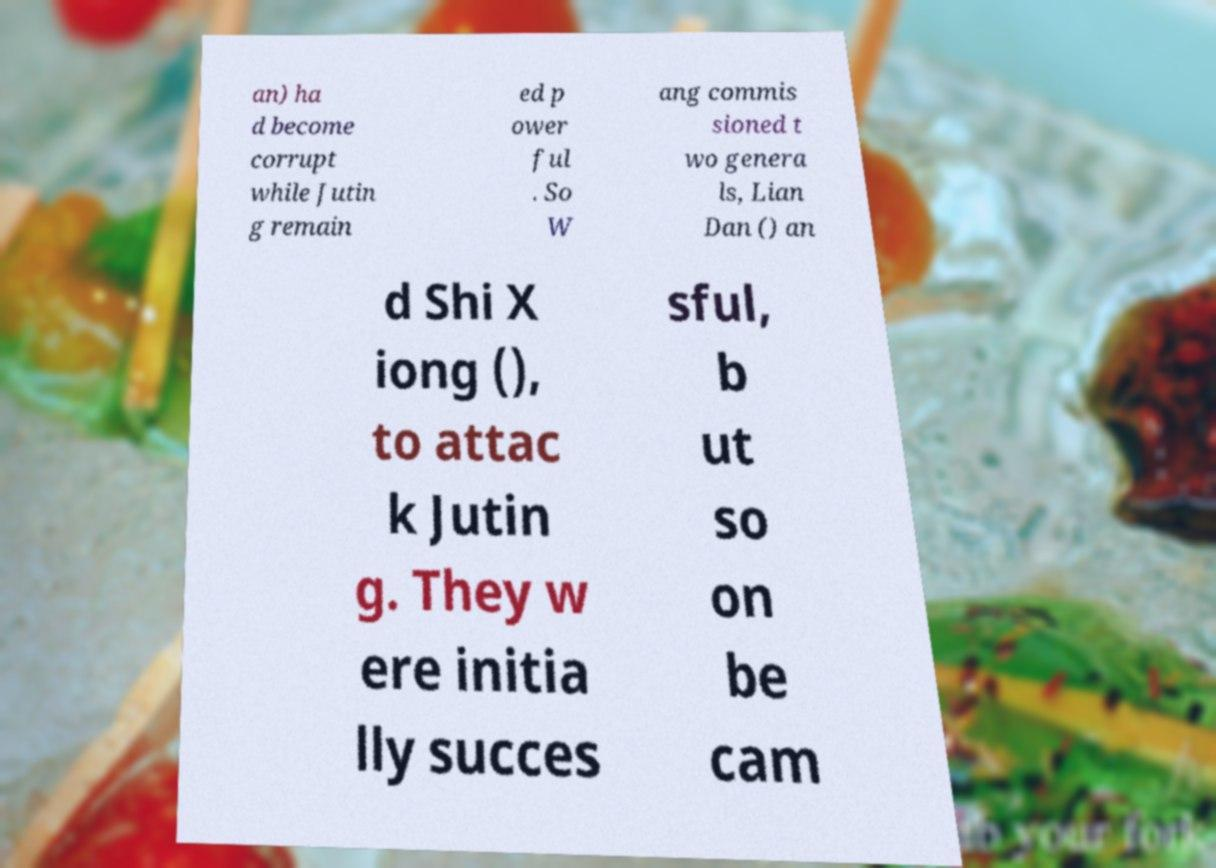What messages or text are displayed in this image? I need them in a readable, typed format. an) ha d become corrupt while Jutin g remain ed p ower ful . So W ang commis sioned t wo genera ls, Lian Dan () an d Shi X iong (), to attac k Jutin g. They w ere initia lly succes sful, b ut so on be cam 